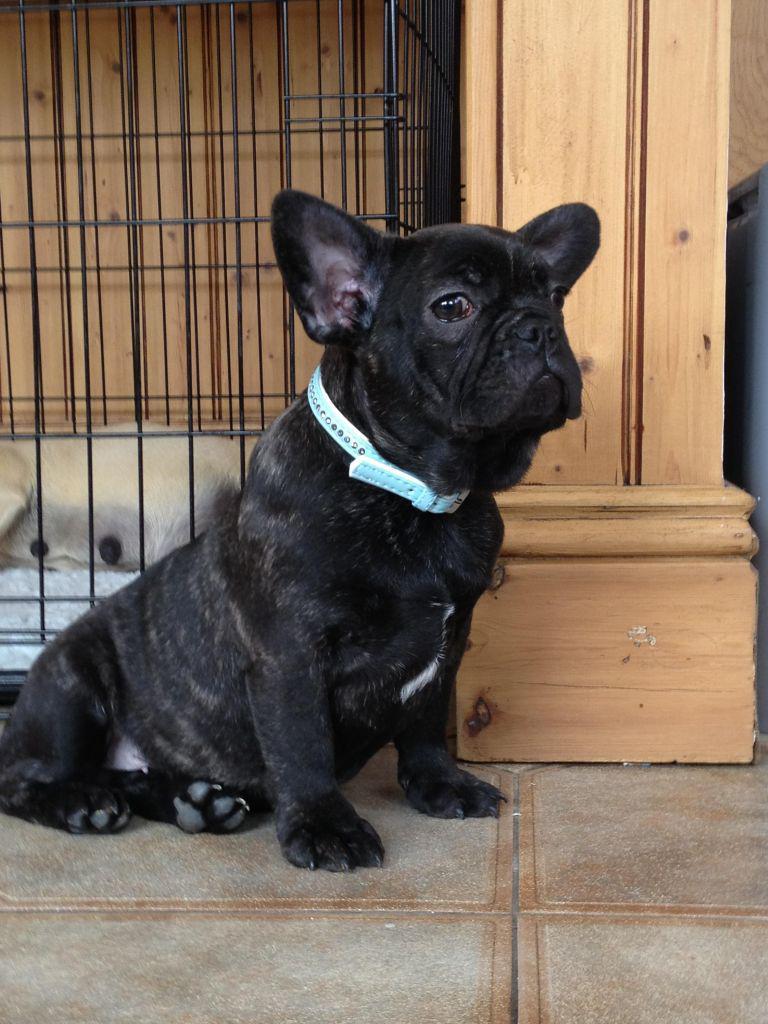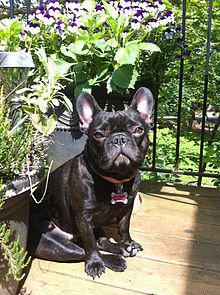The first image is the image on the left, the second image is the image on the right. Assess this claim about the two images: "All the dogs are sitting.". Correct or not? Answer yes or no. Yes. The first image is the image on the left, the second image is the image on the right. For the images shown, is this caption "Each image contains a dark french bulldog in a sitting pose, and the dog in the left image has its body turned rightward while the dog on the right looks directly at the camera." true? Answer yes or no. Yes. 